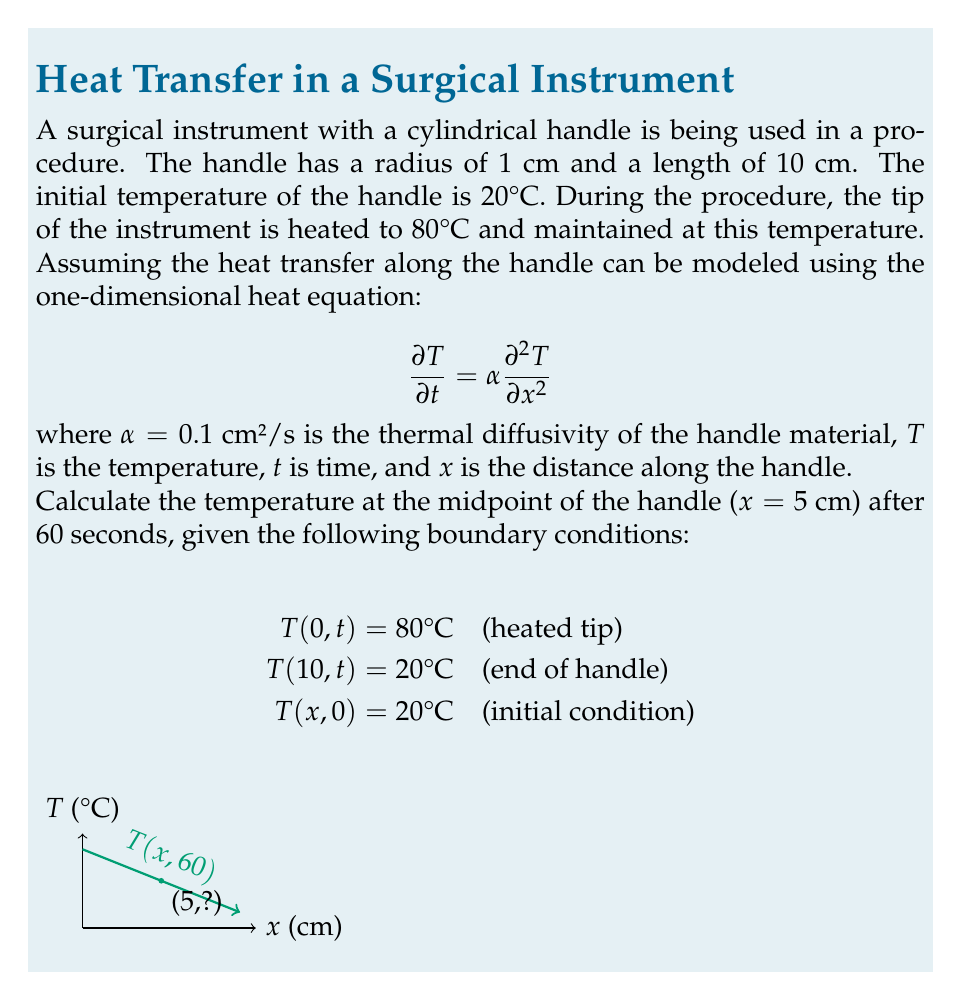Teach me how to tackle this problem. To solve this problem, we'll use the method of separation of variables for the heat equation.

1) First, we seek a solution of the form $T(x,t) = X(x)T(t)$.

2) Substituting this into the heat equation and separating variables, we get:

   $$\frac{T'(t)}{αT(t)} = \frac{X''(x)}{X(x)} = -λ^2$$

3) This leads to two ordinary differential equations:
   
   $T'(t) + αλ^2T(t) = 0$
   $X''(x) + λ^2X(x) = 0$

4) The general solutions are:
   
   $T(t) = Ae^{-αλ^2t}$
   $X(x) = B\sin(λx) + C\cos(λx)$

5) Applying the boundary conditions:
   
   $T(0,t) = 80°C \implies C = 80$
   $T(10,t) = 20°C \implies B\sin(10λ) + 80\cos(10λ) = 20$

6) The eigenvalues λ_n that satisfy these conditions are:
   
   $λ_n = \frac{n\pi}{10}$, where $n = 1, 2, 3, ...$

7) The complete solution is:

   $$T(x,t) = 20 + 60\sum_{n=1}^{\infty} \frac{\sin(\frac{nπx}{10})}{\sin(nπ)}e^{-α(\frac{nπ}{10})^2t}$$

8) For the midpoint (x = 5 cm) at t = 60 s:

   $$T(5,60) = 20 + 60\sum_{n=1}^{\infty} \frac{\sin(\frac{nπ}{2})}{\sin(nπ)}e^{-0.1(\frac{nπ}{10})^2 60}$$

9) Calculating the first few terms of this series (n = 1, 3, 5, as even terms are zero):

   $n=1: 60 \cdot 1 \cdot e^{-0.1(\frac{π}{10})^2 60} ≈ 42.76$
   $n=3: 60 \cdot (-\frac{1}{3}) \cdot e^{-0.1(\frac{3π}{10})^2 60} ≈ -2.15$
   $n=5: 60 \cdot \frac{1}{5} \cdot e^{-0.1(\frac{5π}{10})^2 60} ≈ 0.13$

10) Summing these terms and adding the initial 20°C:

    $T(5,60) ≈ 20 + 42.76 - 2.15 + 0.13 ≈ 60.74°C$
Answer: 60.74°C 